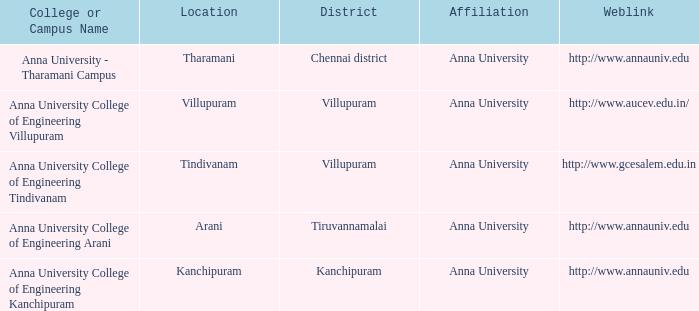What Weblink has a College or Campus Name of anna university college of engineering kanchipuram? Http://www.annauniv.edu. 